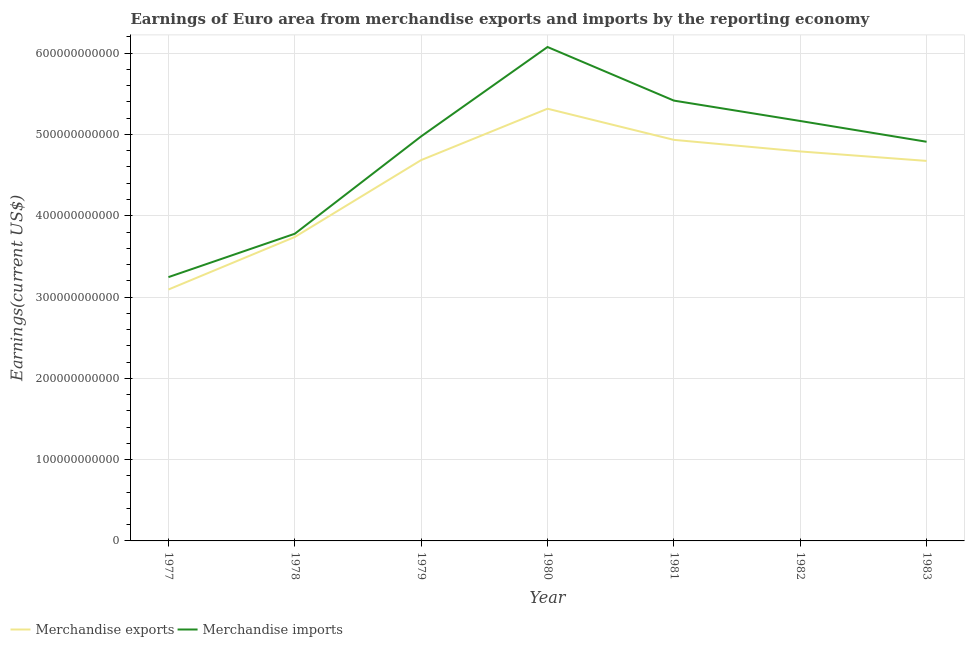Does the line corresponding to earnings from merchandise exports intersect with the line corresponding to earnings from merchandise imports?
Offer a terse response. No. What is the earnings from merchandise exports in 1977?
Ensure brevity in your answer.  3.09e+11. Across all years, what is the maximum earnings from merchandise imports?
Provide a succinct answer. 6.08e+11. Across all years, what is the minimum earnings from merchandise imports?
Offer a very short reply. 3.25e+11. In which year was the earnings from merchandise imports minimum?
Your answer should be compact. 1977. What is the total earnings from merchandise exports in the graph?
Ensure brevity in your answer.  3.12e+12. What is the difference between the earnings from merchandise exports in 1979 and that in 1983?
Your response must be concise. 1.01e+09. What is the difference between the earnings from merchandise exports in 1980 and the earnings from merchandise imports in 1982?
Provide a short and direct response. 1.51e+1. What is the average earnings from merchandise imports per year?
Make the answer very short. 4.80e+11. In the year 1983, what is the difference between the earnings from merchandise exports and earnings from merchandise imports?
Provide a succinct answer. -2.36e+1. What is the ratio of the earnings from merchandise exports in 1980 to that in 1983?
Provide a succinct answer. 1.14. What is the difference between the highest and the second highest earnings from merchandise exports?
Offer a very short reply. 3.83e+1. What is the difference between the highest and the lowest earnings from merchandise imports?
Make the answer very short. 2.83e+11. In how many years, is the earnings from merchandise imports greater than the average earnings from merchandise imports taken over all years?
Provide a succinct answer. 5. Is the sum of the earnings from merchandise imports in 1979 and 1983 greater than the maximum earnings from merchandise exports across all years?
Your answer should be compact. Yes. How many lines are there?
Make the answer very short. 2. How many years are there in the graph?
Ensure brevity in your answer.  7. What is the difference between two consecutive major ticks on the Y-axis?
Give a very brief answer. 1.00e+11. Does the graph contain any zero values?
Offer a terse response. No. Where does the legend appear in the graph?
Ensure brevity in your answer.  Bottom left. How many legend labels are there?
Your response must be concise. 2. What is the title of the graph?
Provide a short and direct response. Earnings of Euro area from merchandise exports and imports by the reporting economy. What is the label or title of the Y-axis?
Give a very brief answer. Earnings(current US$). What is the Earnings(current US$) in Merchandise exports in 1977?
Provide a short and direct response. 3.09e+11. What is the Earnings(current US$) in Merchandise imports in 1977?
Provide a succinct answer. 3.25e+11. What is the Earnings(current US$) of Merchandise exports in 1978?
Keep it short and to the point. 3.74e+11. What is the Earnings(current US$) in Merchandise imports in 1978?
Provide a succinct answer. 3.78e+11. What is the Earnings(current US$) in Merchandise exports in 1979?
Provide a short and direct response. 4.68e+11. What is the Earnings(current US$) of Merchandise imports in 1979?
Provide a succinct answer. 4.98e+11. What is the Earnings(current US$) of Merchandise exports in 1980?
Your answer should be compact. 5.32e+11. What is the Earnings(current US$) of Merchandise imports in 1980?
Ensure brevity in your answer.  6.08e+11. What is the Earnings(current US$) in Merchandise exports in 1981?
Your response must be concise. 4.93e+11. What is the Earnings(current US$) of Merchandise imports in 1981?
Provide a succinct answer. 5.42e+11. What is the Earnings(current US$) in Merchandise exports in 1982?
Provide a succinct answer. 4.79e+11. What is the Earnings(current US$) of Merchandise imports in 1982?
Provide a succinct answer. 5.17e+11. What is the Earnings(current US$) of Merchandise exports in 1983?
Offer a very short reply. 4.67e+11. What is the Earnings(current US$) in Merchandise imports in 1983?
Give a very brief answer. 4.91e+11. Across all years, what is the maximum Earnings(current US$) in Merchandise exports?
Your answer should be very brief. 5.32e+11. Across all years, what is the maximum Earnings(current US$) of Merchandise imports?
Your response must be concise. 6.08e+11. Across all years, what is the minimum Earnings(current US$) of Merchandise exports?
Keep it short and to the point. 3.09e+11. Across all years, what is the minimum Earnings(current US$) in Merchandise imports?
Offer a very short reply. 3.25e+11. What is the total Earnings(current US$) of Merchandise exports in the graph?
Provide a succinct answer. 3.12e+12. What is the total Earnings(current US$) of Merchandise imports in the graph?
Keep it short and to the point. 3.36e+12. What is the difference between the Earnings(current US$) of Merchandise exports in 1977 and that in 1978?
Offer a terse response. -6.46e+1. What is the difference between the Earnings(current US$) of Merchandise imports in 1977 and that in 1978?
Give a very brief answer. -5.34e+1. What is the difference between the Earnings(current US$) in Merchandise exports in 1977 and that in 1979?
Provide a short and direct response. -1.59e+11. What is the difference between the Earnings(current US$) in Merchandise imports in 1977 and that in 1979?
Make the answer very short. -1.73e+11. What is the difference between the Earnings(current US$) in Merchandise exports in 1977 and that in 1980?
Provide a short and direct response. -2.22e+11. What is the difference between the Earnings(current US$) in Merchandise imports in 1977 and that in 1980?
Your answer should be compact. -2.83e+11. What is the difference between the Earnings(current US$) of Merchandise exports in 1977 and that in 1981?
Provide a short and direct response. -1.84e+11. What is the difference between the Earnings(current US$) of Merchandise imports in 1977 and that in 1981?
Your answer should be compact. -2.17e+11. What is the difference between the Earnings(current US$) in Merchandise exports in 1977 and that in 1982?
Give a very brief answer. -1.70e+11. What is the difference between the Earnings(current US$) of Merchandise imports in 1977 and that in 1982?
Offer a terse response. -1.92e+11. What is the difference between the Earnings(current US$) in Merchandise exports in 1977 and that in 1983?
Your response must be concise. -1.58e+11. What is the difference between the Earnings(current US$) of Merchandise imports in 1977 and that in 1983?
Make the answer very short. -1.67e+11. What is the difference between the Earnings(current US$) in Merchandise exports in 1978 and that in 1979?
Provide a succinct answer. -9.46e+1. What is the difference between the Earnings(current US$) of Merchandise imports in 1978 and that in 1979?
Offer a very short reply. -1.20e+11. What is the difference between the Earnings(current US$) in Merchandise exports in 1978 and that in 1980?
Keep it short and to the point. -1.58e+11. What is the difference between the Earnings(current US$) of Merchandise imports in 1978 and that in 1980?
Your answer should be very brief. -2.30e+11. What is the difference between the Earnings(current US$) of Merchandise exports in 1978 and that in 1981?
Keep it short and to the point. -1.19e+11. What is the difference between the Earnings(current US$) of Merchandise imports in 1978 and that in 1981?
Keep it short and to the point. -1.64e+11. What is the difference between the Earnings(current US$) of Merchandise exports in 1978 and that in 1982?
Provide a succinct answer. -1.05e+11. What is the difference between the Earnings(current US$) in Merchandise imports in 1978 and that in 1982?
Your answer should be compact. -1.39e+11. What is the difference between the Earnings(current US$) in Merchandise exports in 1978 and that in 1983?
Provide a succinct answer. -9.36e+1. What is the difference between the Earnings(current US$) of Merchandise imports in 1978 and that in 1983?
Your answer should be compact. -1.13e+11. What is the difference between the Earnings(current US$) in Merchandise exports in 1979 and that in 1980?
Your response must be concise. -6.32e+1. What is the difference between the Earnings(current US$) in Merchandise imports in 1979 and that in 1980?
Offer a very short reply. -1.10e+11. What is the difference between the Earnings(current US$) of Merchandise exports in 1979 and that in 1981?
Provide a succinct answer. -2.49e+1. What is the difference between the Earnings(current US$) of Merchandise imports in 1979 and that in 1981?
Offer a very short reply. -4.40e+1. What is the difference between the Earnings(current US$) of Merchandise exports in 1979 and that in 1982?
Give a very brief answer. -1.06e+1. What is the difference between the Earnings(current US$) in Merchandise imports in 1979 and that in 1982?
Your answer should be very brief. -1.89e+1. What is the difference between the Earnings(current US$) of Merchandise exports in 1979 and that in 1983?
Your answer should be very brief. 1.01e+09. What is the difference between the Earnings(current US$) of Merchandise imports in 1979 and that in 1983?
Your response must be concise. 6.65e+09. What is the difference between the Earnings(current US$) of Merchandise exports in 1980 and that in 1981?
Your answer should be compact. 3.83e+1. What is the difference between the Earnings(current US$) of Merchandise imports in 1980 and that in 1981?
Make the answer very short. 6.59e+1. What is the difference between the Earnings(current US$) in Merchandise exports in 1980 and that in 1982?
Keep it short and to the point. 5.26e+1. What is the difference between the Earnings(current US$) in Merchandise imports in 1980 and that in 1982?
Your response must be concise. 9.10e+1. What is the difference between the Earnings(current US$) of Merchandise exports in 1980 and that in 1983?
Provide a short and direct response. 6.42e+1. What is the difference between the Earnings(current US$) in Merchandise imports in 1980 and that in 1983?
Keep it short and to the point. 1.17e+11. What is the difference between the Earnings(current US$) of Merchandise exports in 1981 and that in 1982?
Provide a succinct answer. 1.43e+1. What is the difference between the Earnings(current US$) of Merchandise imports in 1981 and that in 1982?
Your answer should be compact. 2.51e+1. What is the difference between the Earnings(current US$) of Merchandise exports in 1981 and that in 1983?
Keep it short and to the point. 2.59e+1. What is the difference between the Earnings(current US$) of Merchandise imports in 1981 and that in 1983?
Your response must be concise. 5.06e+1. What is the difference between the Earnings(current US$) in Merchandise exports in 1982 and that in 1983?
Your answer should be very brief. 1.16e+1. What is the difference between the Earnings(current US$) in Merchandise imports in 1982 and that in 1983?
Make the answer very short. 2.56e+1. What is the difference between the Earnings(current US$) in Merchandise exports in 1977 and the Earnings(current US$) in Merchandise imports in 1978?
Offer a terse response. -6.86e+1. What is the difference between the Earnings(current US$) of Merchandise exports in 1977 and the Earnings(current US$) of Merchandise imports in 1979?
Your answer should be very brief. -1.88e+11. What is the difference between the Earnings(current US$) in Merchandise exports in 1977 and the Earnings(current US$) in Merchandise imports in 1980?
Make the answer very short. -2.98e+11. What is the difference between the Earnings(current US$) in Merchandise exports in 1977 and the Earnings(current US$) in Merchandise imports in 1981?
Offer a very short reply. -2.32e+11. What is the difference between the Earnings(current US$) of Merchandise exports in 1977 and the Earnings(current US$) of Merchandise imports in 1982?
Your response must be concise. -2.07e+11. What is the difference between the Earnings(current US$) of Merchandise exports in 1977 and the Earnings(current US$) of Merchandise imports in 1983?
Provide a short and direct response. -1.82e+11. What is the difference between the Earnings(current US$) in Merchandise exports in 1978 and the Earnings(current US$) in Merchandise imports in 1979?
Offer a very short reply. -1.24e+11. What is the difference between the Earnings(current US$) in Merchandise exports in 1978 and the Earnings(current US$) in Merchandise imports in 1980?
Give a very brief answer. -2.34e+11. What is the difference between the Earnings(current US$) of Merchandise exports in 1978 and the Earnings(current US$) of Merchandise imports in 1981?
Your answer should be compact. -1.68e+11. What is the difference between the Earnings(current US$) in Merchandise exports in 1978 and the Earnings(current US$) in Merchandise imports in 1982?
Offer a terse response. -1.43e+11. What is the difference between the Earnings(current US$) of Merchandise exports in 1978 and the Earnings(current US$) of Merchandise imports in 1983?
Your answer should be compact. -1.17e+11. What is the difference between the Earnings(current US$) of Merchandise exports in 1979 and the Earnings(current US$) of Merchandise imports in 1980?
Offer a terse response. -1.39e+11. What is the difference between the Earnings(current US$) of Merchandise exports in 1979 and the Earnings(current US$) of Merchandise imports in 1981?
Keep it short and to the point. -7.32e+1. What is the difference between the Earnings(current US$) in Merchandise exports in 1979 and the Earnings(current US$) in Merchandise imports in 1982?
Provide a short and direct response. -4.81e+1. What is the difference between the Earnings(current US$) of Merchandise exports in 1979 and the Earnings(current US$) of Merchandise imports in 1983?
Offer a terse response. -2.26e+1. What is the difference between the Earnings(current US$) in Merchandise exports in 1980 and the Earnings(current US$) in Merchandise imports in 1981?
Provide a succinct answer. -9.98e+09. What is the difference between the Earnings(current US$) of Merchandise exports in 1980 and the Earnings(current US$) of Merchandise imports in 1982?
Ensure brevity in your answer.  1.51e+1. What is the difference between the Earnings(current US$) in Merchandise exports in 1980 and the Earnings(current US$) in Merchandise imports in 1983?
Make the answer very short. 4.06e+1. What is the difference between the Earnings(current US$) in Merchandise exports in 1981 and the Earnings(current US$) in Merchandise imports in 1982?
Your answer should be compact. -2.32e+1. What is the difference between the Earnings(current US$) of Merchandise exports in 1981 and the Earnings(current US$) of Merchandise imports in 1983?
Provide a succinct answer. 2.34e+09. What is the difference between the Earnings(current US$) in Merchandise exports in 1982 and the Earnings(current US$) in Merchandise imports in 1983?
Your answer should be compact. -1.19e+1. What is the average Earnings(current US$) of Merchandise exports per year?
Ensure brevity in your answer.  4.46e+11. What is the average Earnings(current US$) in Merchandise imports per year?
Offer a terse response. 4.80e+11. In the year 1977, what is the difference between the Earnings(current US$) in Merchandise exports and Earnings(current US$) in Merchandise imports?
Your answer should be very brief. -1.53e+1. In the year 1978, what is the difference between the Earnings(current US$) of Merchandise exports and Earnings(current US$) of Merchandise imports?
Offer a very short reply. -3.99e+09. In the year 1979, what is the difference between the Earnings(current US$) in Merchandise exports and Earnings(current US$) in Merchandise imports?
Offer a terse response. -2.92e+1. In the year 1980, what is the difference between the Earnings(current US$) of Merchandise exports and Earnings(current US$) of Merchandise imports?
Offer a terse response. -7.59e+1. In the year 1981, what is the difference between the Earnings(current US$) in Merchandise exports and Earnings(current US$) in Merchandise imports?
Give a very brief answer. -4.83e+1. In the year 1982, what is the difference between the Earnings(current US$) in Merchandise exports and Earnings(current US$) in Merchandise imports?
Provide a short and direct response. -3.75e+1. In the year 1983, what is the difference between the Earnings(current US$) in Merchandise exports and Earnings(current US$) in Merchandise imports?
Offer a terse response. -2.36e+1. What is the ratio of the Earnings(current US$) of Merchandise exports in 1977 to that in 1978?
Give a very brief answer. 0.83. What is the ratio of the Earnings(current US$) in Merchandise imports in 1977 to that in 1978?
Provide a succinct answer. 0.86. What is the ratio of the Earnings(current US$) of Merchandise exports in 1977 to that in 1979?
Give a very brief answer. 0.66. What is the ratio of the Earnings(current US$) in Merchandise imports in 1977 to that in 1979?
Provide a succinct answer. 0.65. What is the ratio of the Earnings(current US$) in Merchandise exports in 1977 to that in 1980?
Provide a succinct answer. 0.58. What is the ratio of the Earnings(current US$) in Merchandise imports in 1977 to that in 1980?
Your response must be concise. 0.53. What is the ratio of the Earnings(current US$) of Merchandise exports in 1977 to that in 1981?
Offer a terse response. 0.63. What is the ratio of the Earnings(current US$) in Merchandise imports in 1977 to that in 1981?
Your answer should be very brief. 0.6. What is the ratio of the Earnings(current US$) in Merchandise exports in 1977 to that in 1982?
Your answer should be very brief. 0.65. What is the ratio of the Earnings(current US$) in Merchandise imports in 1977 to that in 1982?
Keep it short and to the point. 0.63. What is the ratio of the Earnings(current US$) in Merchandise exports in 1977 to that in 1983?
Offer a very short reply. 0.66. What is the ratio of the Earnings(current US$) in Merchandise imports in 1977 to that in 1983?
Provide a succinct answer. 0.66. What is the ratio of the Earnings(current US$) in Merchandise exports in 1978 to that in 1979?
Make the answer very short. 0.8. What is the ratio of the Earnings(current US$) in Merchandise imports in 1978 to that in 1979?
Ensure brevity in your answer.  0.76. What is the ratio of the Earnings(current US$) of Merchandise exports in 1978 to that in 1980?
Make the answer very short. 0.7. What is the ratio of the Earnings(current US$) of Merchandise imports in 1978 to that in 1980?
Your answer should be compact. 0.62. What is the ratio of the Earnings(current US$) in Merchandise exports in 1978 to that in 1981?
Your answer should be compact. 0.76. What is the ratio of the Earnings(current US$) of Merchandise imports in 1978 to that in 1981?
Your response must be concise. 0.7. What is the ratio of the Earnings(current US$) of Merchandise exports in 1978 to that in 1982?
Your answer should be very brief. 0.78. What is the ratio of the Earnings(current US$) in Merchandise imports in 1978 to that in 1982?
Offer a terse response. 0.73. What is the ratio of the Earnings(current US$) of Merchandise exports in 1978 to that in 1983?
Offer a terse response. 0.8. What is the ratio of the Earnings(current US$) in Merchandise imports in 1978 to that in 1983?
Provide a short and direct response. 0.77. What is the ratio of the Earnings(current US$) in Merchandise exports in 1979 to that in 1980?
Give a very brief answer. 0.88. What is the ratio of the Earnings(current US$) of Merchandise imports in 1979 to that in 1980?
Provide a short and direct response. 0.82. What is the ratio of the Earnings(current US$) of Merchandise exports in 1979 to that in 1981?
Make the answer very short. 0.95. What is the ratio of the Earnings(current US$) of Merchandise imports in 1979 to that in 1981?
Ensure brevity in your answer.  0.92. What is the ratio of the Earnings(current US$) in Merchandise exports in 1979 to that in 1982?
Make the answer very short. 0.98. What is the ratio of the Earnings(current US$) in Merchandise imports in 1979 to that in 1982?
Keep it short and to the point. 0.96. What is the ratio of the Earnings(current US$) of Merchandise exports in 1979 to that in 1983?
Offer a terse response. 1. What is the ratio of the Earnings(current US$) of Merchandise imports in 1979 to that in 1983?
Provide a short and direct response. 1.01. What is the ratio of the Earnings(current US$) of Merchandise exports in 1980 to that in 1981?
Provide a succinct answer. 1.08. What is the ratio of the Earnings(current US$) of Merchandise imports in 1980 to that in 1981?
Make the answer very short. 1.12. What is the ratio of the Earnings(current US$) of Merchandise exports in 1980 to that in 1982?
Make the answer very short. 1.11. What is the ratio of the Earnings(current US$) of Merchandise imports in 1980 to that in 1982?
Offer a terse response. 1.18. What is the ratio of the Earnings(current US$) of Merchandise exports in 1980 to that in 1983?
Your answer should be compact. 1.14. What is the ratio of the Earnings(current US$) in Merchandise imports in 1980 to that in 1983?
Your answer should be compact. 1.24. What is the ratio of the Earnings(current US$) of Merchandise exports in 1981 to that in 1982?
Your answer should be compact. 1.03. What is the ratio of the Earnings(current US$) in Merchandise imports in 1981 to that in 1982?
Your answer should be very brief. 1.05. What is the ratio of the Earnings(current US$) of Merchandise exports in 1981 to that in 1983?
Provide a short and direct response. 1.06. What is the ratio of the Earnings(current US$) of Merchandise imports in 1981 to that in 1983?
Ensure brevity in your answer.  1.1. What is the ratio of the Earnings(current US$) of Merchandise exports in 1982 to that in 1983?
Offer a very short reply. 1.02. What is the ratio of the Earnings(current US$) of Merchandise imports in 1982 to that in 1983?
Keep it short and to the point. 1.05. What is the difference between the highest and the second highest Earnings(current US$) in Merchandise exports?
Keep it short and to the point. 3.83e+1. What is the difference between the highest and the second highest Earnings(current US$) in Merchandise imports?
Give a very brief answer. 6.59e+1. What is the difference between the highest and the lowest Earnings(current US$) of Merchandise exports?
Make the answer very short. 2.22e+11. What is the difference between the highest and the lowest Earnings(current US$) in Merchandise imports?
Provide a short and direct response. 2.83e+11. 